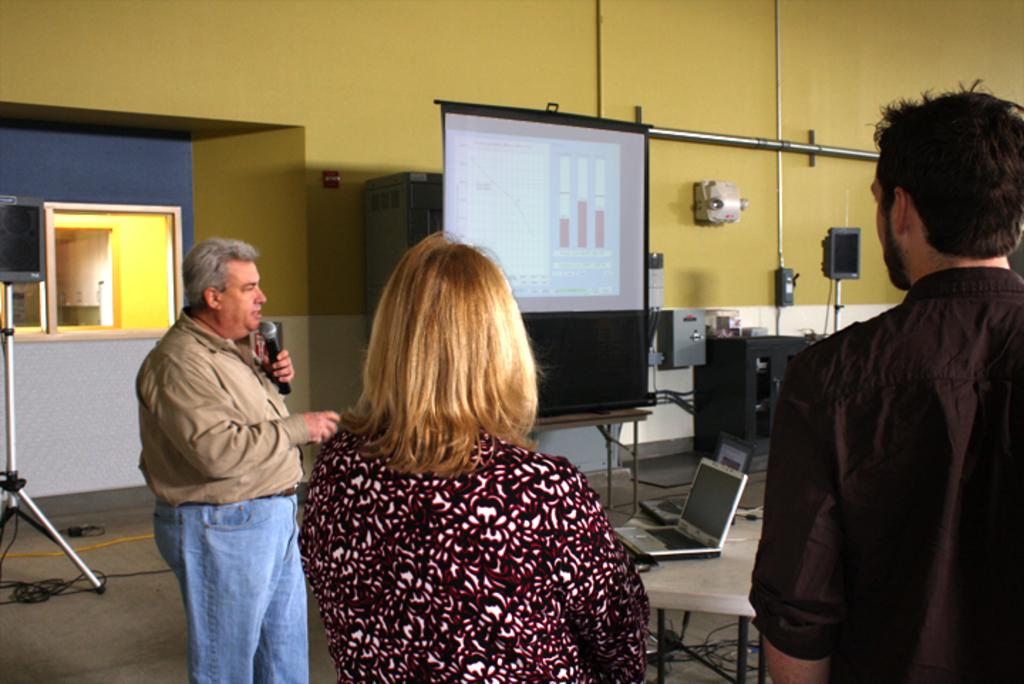What is the man in the image doing? The man is holding a mic in his hand and speaking. Who else is present in the image besides the man? There is a couple in the image. What is the couple doing in the image? The couple is listening to the man. What type of creature is making the alarm sound in the image? There is no creature or alarm sound present in the image. What line is the man speaking in the image? The image does not provide information about the man's speech. 